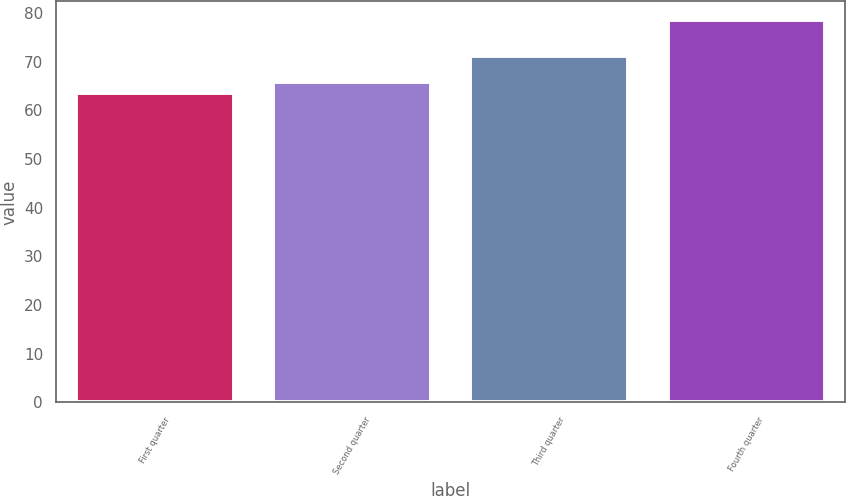<chart> <loc_0><loc_0><loc_500><loc_500><bar_chart><fcel>First quarter<fcel>Second quarter<fcel>Third quarter<fcel>Fourth quarter<nl><fcel>63.45<fcel>65.81<fcel>71.13<fcel>78.46<nl></chart> 